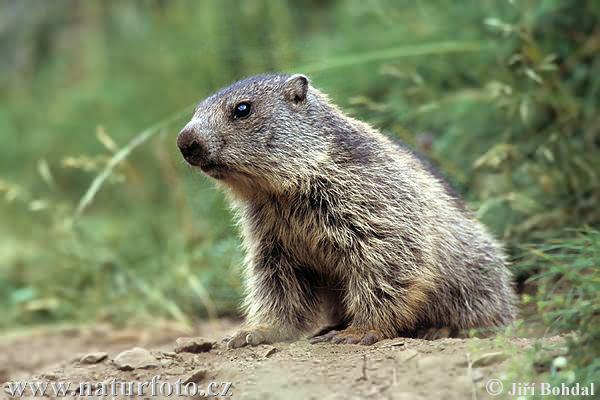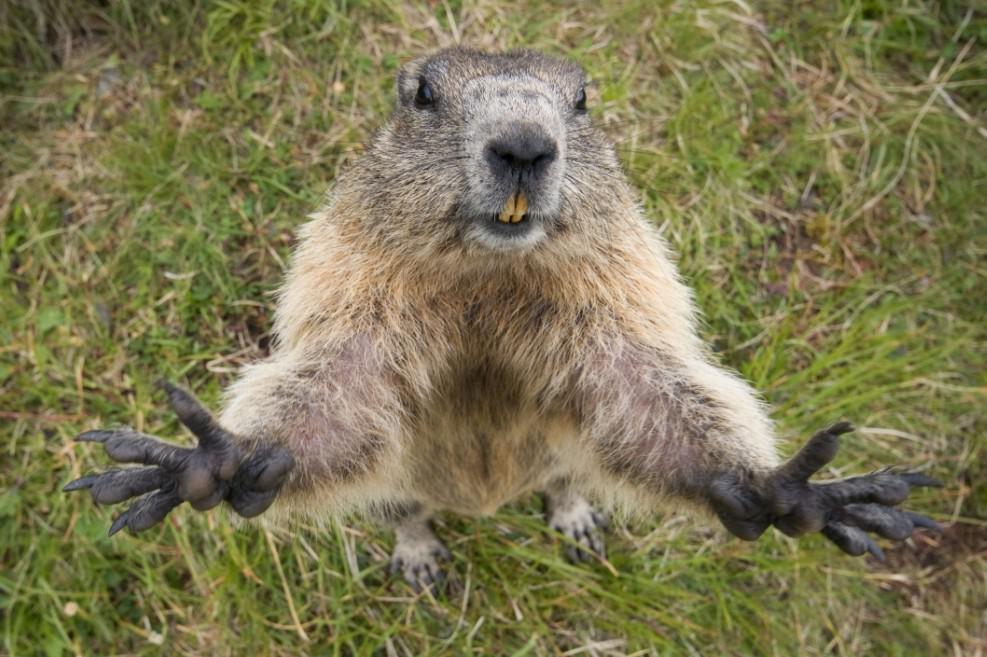The first image is the image on the left, the second image is the image on the right. Analyze the images presented: Is the assertion "In 1 of the images, 1 groundhog is holding an object with its forelimbs." valid? Answer yes or no. No. The first image is the image on the left, the second image is the image on the right. Given the left and right images, does the statement "An image shows marmot with hands raised and close to each other." hold true? Answer yes or no. No. 